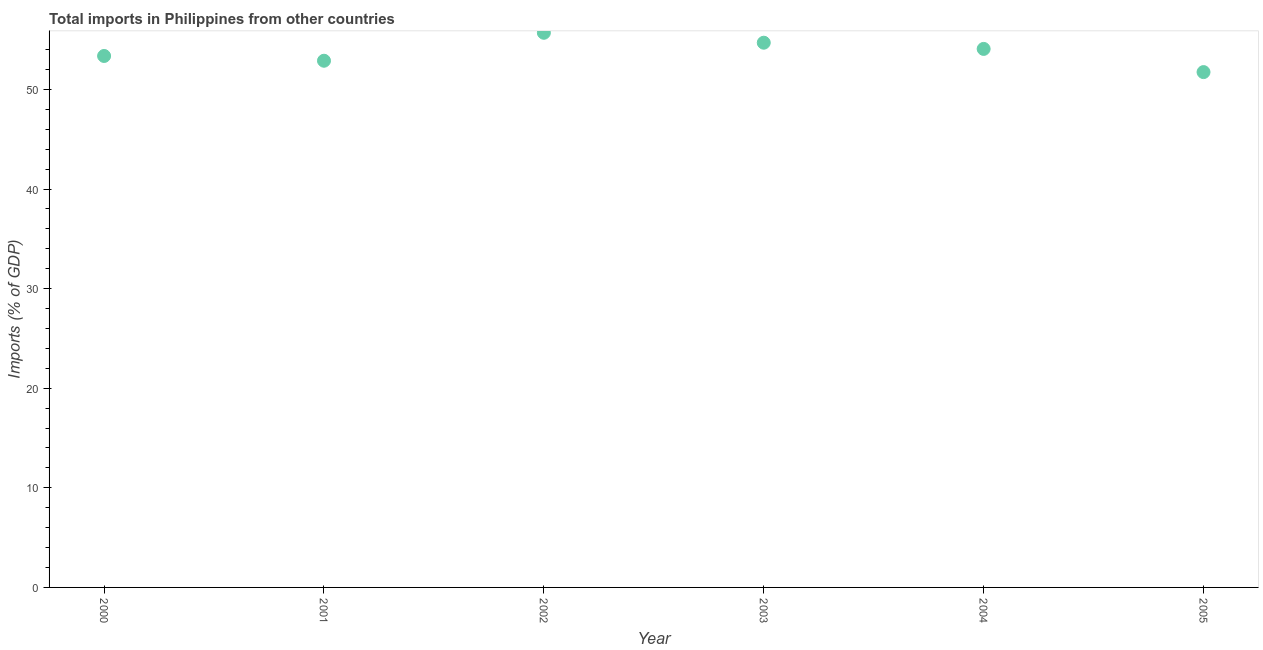What is the total imports in 2003?
Offer a terse response. 54.69. Across all years, what is the maximum total imports?
Give a very brief answer. 55.69. Across all years, what is the minimum total imports?
Give a very brief answer. 51.74. In which year was the total imports minimum?
Keep it short and to the point. 2005. What is the sum of the total imports?
Keep it short and to the point. 322.43. What is the difference between the total imports in 2000 and 2005?
Ensure brevity in your answer.  1.62. What is the average total imports per year?
Make the answer very short. 53.74. What is the median total imports?
Provide a short and direct response. 53.72. In how many years, is the total imports greater than 22 %?
Offer a terse response. 6. Do a majority of the years between 2004 and 2000 (inclusive) have total imports greater than 30 %?
Provide a short and direct response. Yes. What is the ratio of the total imports in 2003 to that in 2005?
Your answer should be very brief. 1.06. Is the difference between the total imports in 2001 and 2004 greater than the difference between any two years?
Provide a short and direct response. No. What is the difference between the highest and the second highest total imports?
Ensure brevity in your answer.  1. Is the sum of the total imports in 2003 and 2005 greater than the maximum total imports across all years?
Your answer should be compact. Yes. What is the difference between the highest and the lowest total imports?
Offer a terse response. 3.95. How many dotlines are there?
Make the answer very short. 1. What is the difference between two consecutive major ticks on the Y-axis?
Provide a short and direct response. 10. Does the graph contain any zero values?
Offer a very short reply. No. Does the graph contain grids?
Give a very brief answer. No. What is the title of the graph?
Give a very brief answer. Total imports in Philippines from other countries. What is the label or title of the Y-axis?
Ensure brevity in your answer.  Imports (% of GDP). What is the Imports (% of GDP) in 2000?
Your response must be concise. 53.36. What is the Imports (% of GDP) in 2001?
Offer a terse response. 52.88. What is the Imports (% of GDP) in 2002?
Your answer should be compact. 55.69. What is the Imports (% of GDP) in 2003?
Your response must be concise. 54.69. What is the Imports (% of GDP) in 2004?
Provide a succinct answer. 54.07. What is the Imports (% of GDP) in 2005?
Your answer should be very brief. 51.74. What is the difference between the Imports (% of GDP) in 2000 and 2001?
Offer a very short reply. 0.48. What is the difference between the Imports (% of GDP) in 2000 and 2002?
Offer a very short reply. -2.33. What is the difference between the Imports (% of GDP) in 2000 and 2003?
Your answer should be compact. -1.33. What is the difference between the Imports (% of GDP) in 2000 and 2004?
Keep it short and to the point. -0.71. What is the difference between the Imports (% of GDP) in 2000 and 2005?
Keep it short and to the point. 1.62. What is the difference between the Imports (% of GDP) in 2001 and 2002?
Your answer should be very brief. -2.81. What is the difference between the Imports (% of GDP) in 2001 and 2003?
Your response must be concise. -1.81. What is the difference between the Imports (% of GDP) in 2001 and 2004?
Keep it short and to the point. -1.19. What is the difference between the Imports (% of GDP) in 2001 and 2005?
Give a very brief answer. 1.14. What is the difference between the Imports (% of GDP) in 2002 and 2004?
Ensure brevity in your answer.  1.62. What is the difference between the Imports (% of GDP) in 2002 and 2005?
Your answer should be compact. 3.95. What is the difference between the Imports (% of GDP) in 2003 and 2004?
Provide a short and direct response. 0.62. What is the difference between the Imports (% of GDP) in 2003 and 2005?
Provide a short and direct response. 2.95. What is the difference between the Imports (% of GDP) in 2004 and 2005?
Give a very brief answer. 2.33. What is the ratio of the Imports (% of GDP) in 2000 to that in 2001?
Provide a succinct answer. 1.01. What is the ratio of the Imports (% of GDP) in 2000 to that in 2002?
Provide a short and direct response. 0.96. What is the ratio of the Imports (% of GDP) in 2000 to that in 2005?
Keep it short and to the point. 1.03. What is the ratio of the Imports (% of GDP) in 2001 to that in 2002?
Give a very brief answer. 0.95. What is the ratio of the Imports (% of GDP) in 2001 to that in 2004?
Your answer should be compact. 0.98. What is the ratio of the Imports (% of GDP) in 2002 to that in 2004?
Offer a very short reply. 1.03. What is the ratio of the Imports (% of GDP) in 2002 to that in 2005?
Your answer should be very brief. 1.08. What is the ratio of the Imports (% of GDP) in 2003 to that in 2005?
Your answer should be very brief. 1.06. What is the ratio of the Imports (% of GDP) in 2004 to that in 2005?
Your answer should be compact. 1.04. 